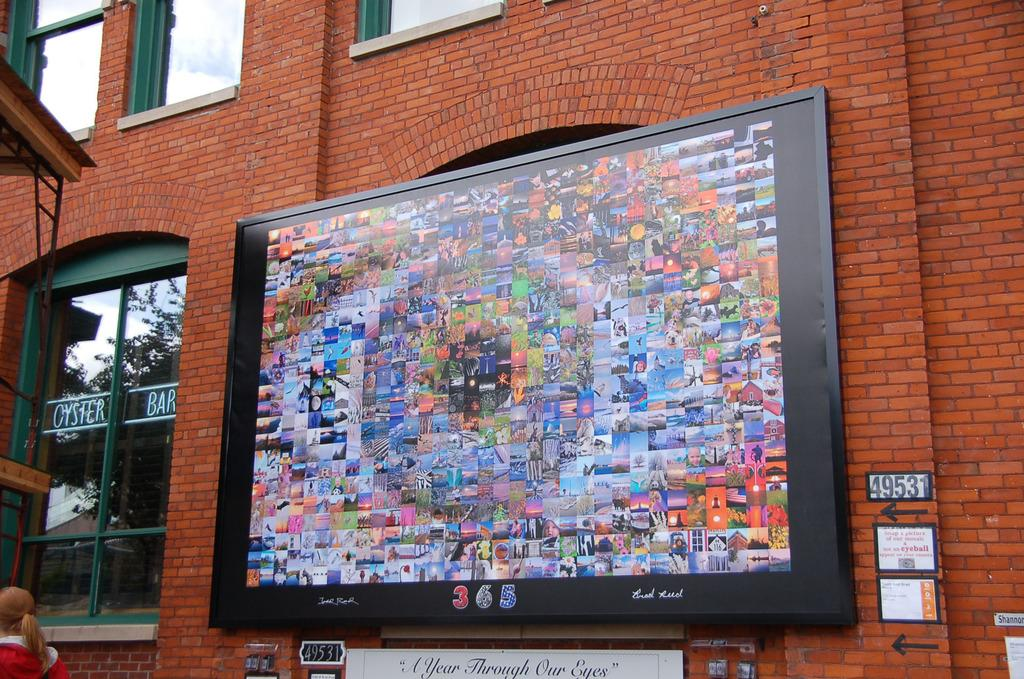What type of structure is visible in the image? There is a building wall in the image. What is attached to the building wall? There is a hoarding in the image. Are there any openings in the building wall? Yes, there are windows in the image. Can you describe the person in the image? There is a person in the image. When was the image taken? The image was taken during the day. What type of establishment is nearby in the image? The image was taken near a restaurant. What is the cause of the toad's sudden disappearance in the image? There is no toad present in the image, so it is not possible to determine the cause of any disappearance. 